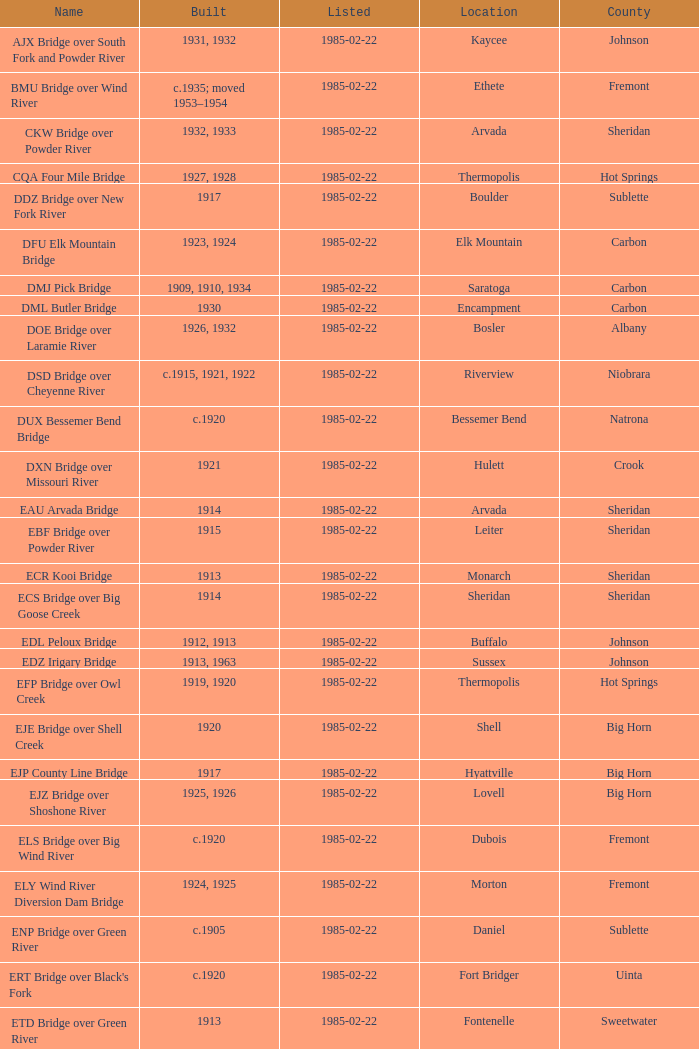What is the listed for the bridge at Daniel in Sublette county? 1985-02-22. 